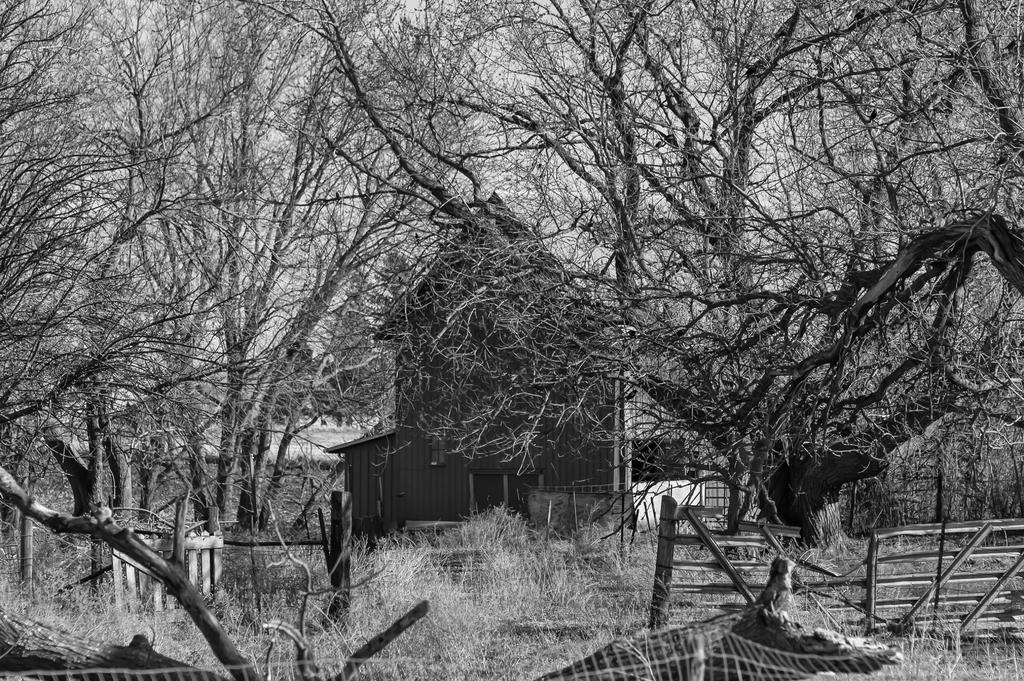What is the color scheme of the image? The image is black and white. What type of structure can be seen in the image? There is a wooden fence in the image. What natural elements are present in the image? Branches and trees are visible in the image. What type of building is in the image? There is a house in the image. What is visible behind the house? The sky is visible behind the house. Can you see a curtain blowing in the wind in the image? There is no curtain present in the image. What type of error is visible in the image? There is no error present in the image; it is a clear and accurate representation of the scene. 